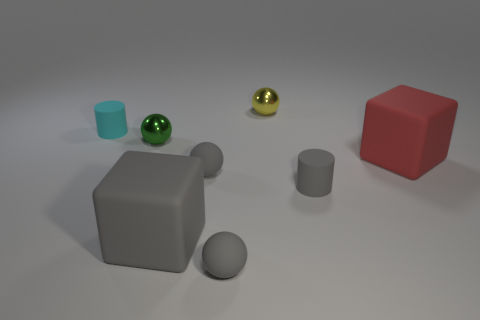How many small green objects have the same material as the yellow sphere?
Your response must be concise. 1. What number of tiny yellow objects are on the right side of the tiny yellow metallic thing?
Offer a terse response. 0. How big is the red matte cube?
Your answer should be compact. Large. What color is the other rubber block that is the same size as the gray block?
Provide a succinct answer. Red. What is the material of the tiny yellow thing?
Your answer should be compact. Metal. How many tiny blue spheres are there?
Ensure brevity in your answer.  0. There is a block that is on the left side of the yellow thing; is its color the same as the tiny rubber ball in front of the big gray matte thing?
Offer a terse response. Yes. What number of other things are the same size as the red matte block?
Your answer should be very brief. 1. The metallic thing on the right side of the tiny green object is what color?
Offer a very short reply. Yellow. Is the cylinder on the right side of the tiny green object made of the same material as the small green ball?
Your answer should be very brief. No. 